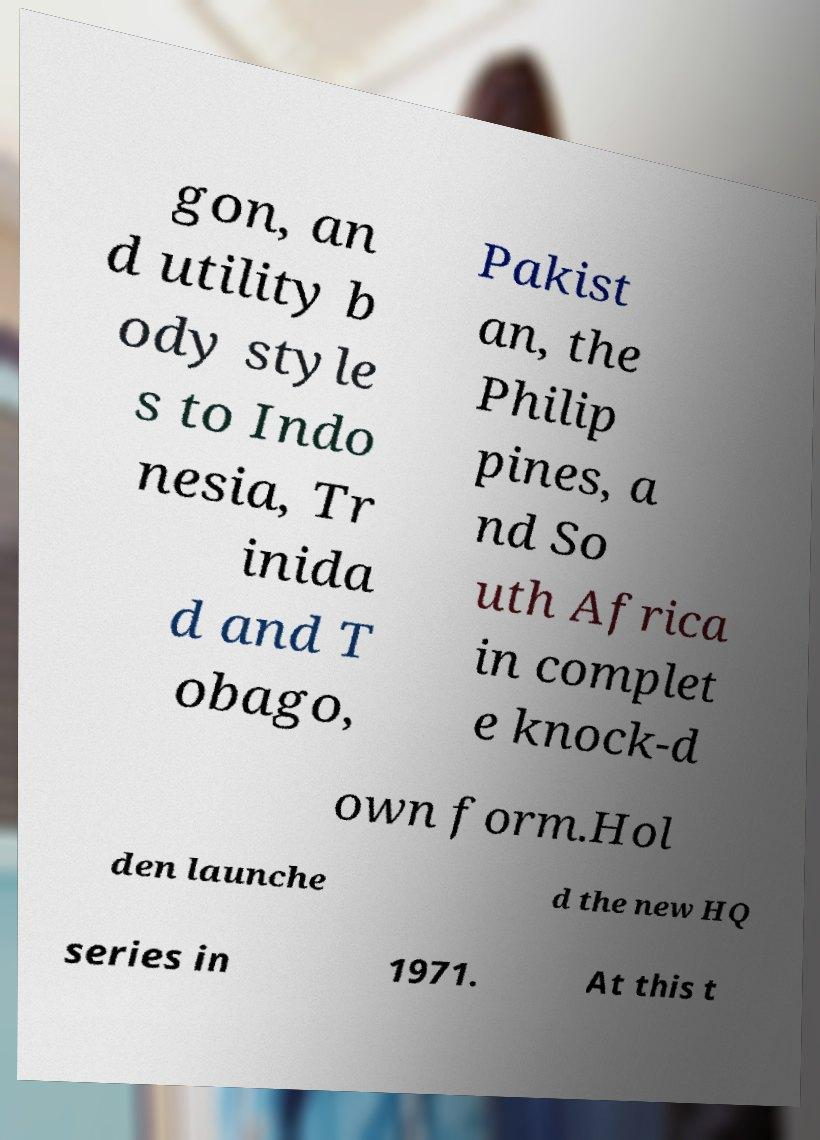Please read and relay the text visible in this image. What does it say? gon, an d utility b ody style s to Indo nesia, Tr inida d and T obago, Pakist an, the Philip pines, a nd So uth Africa in complet e knock-d own form.Hol den launche d the new HQ series in 1971. At this t 